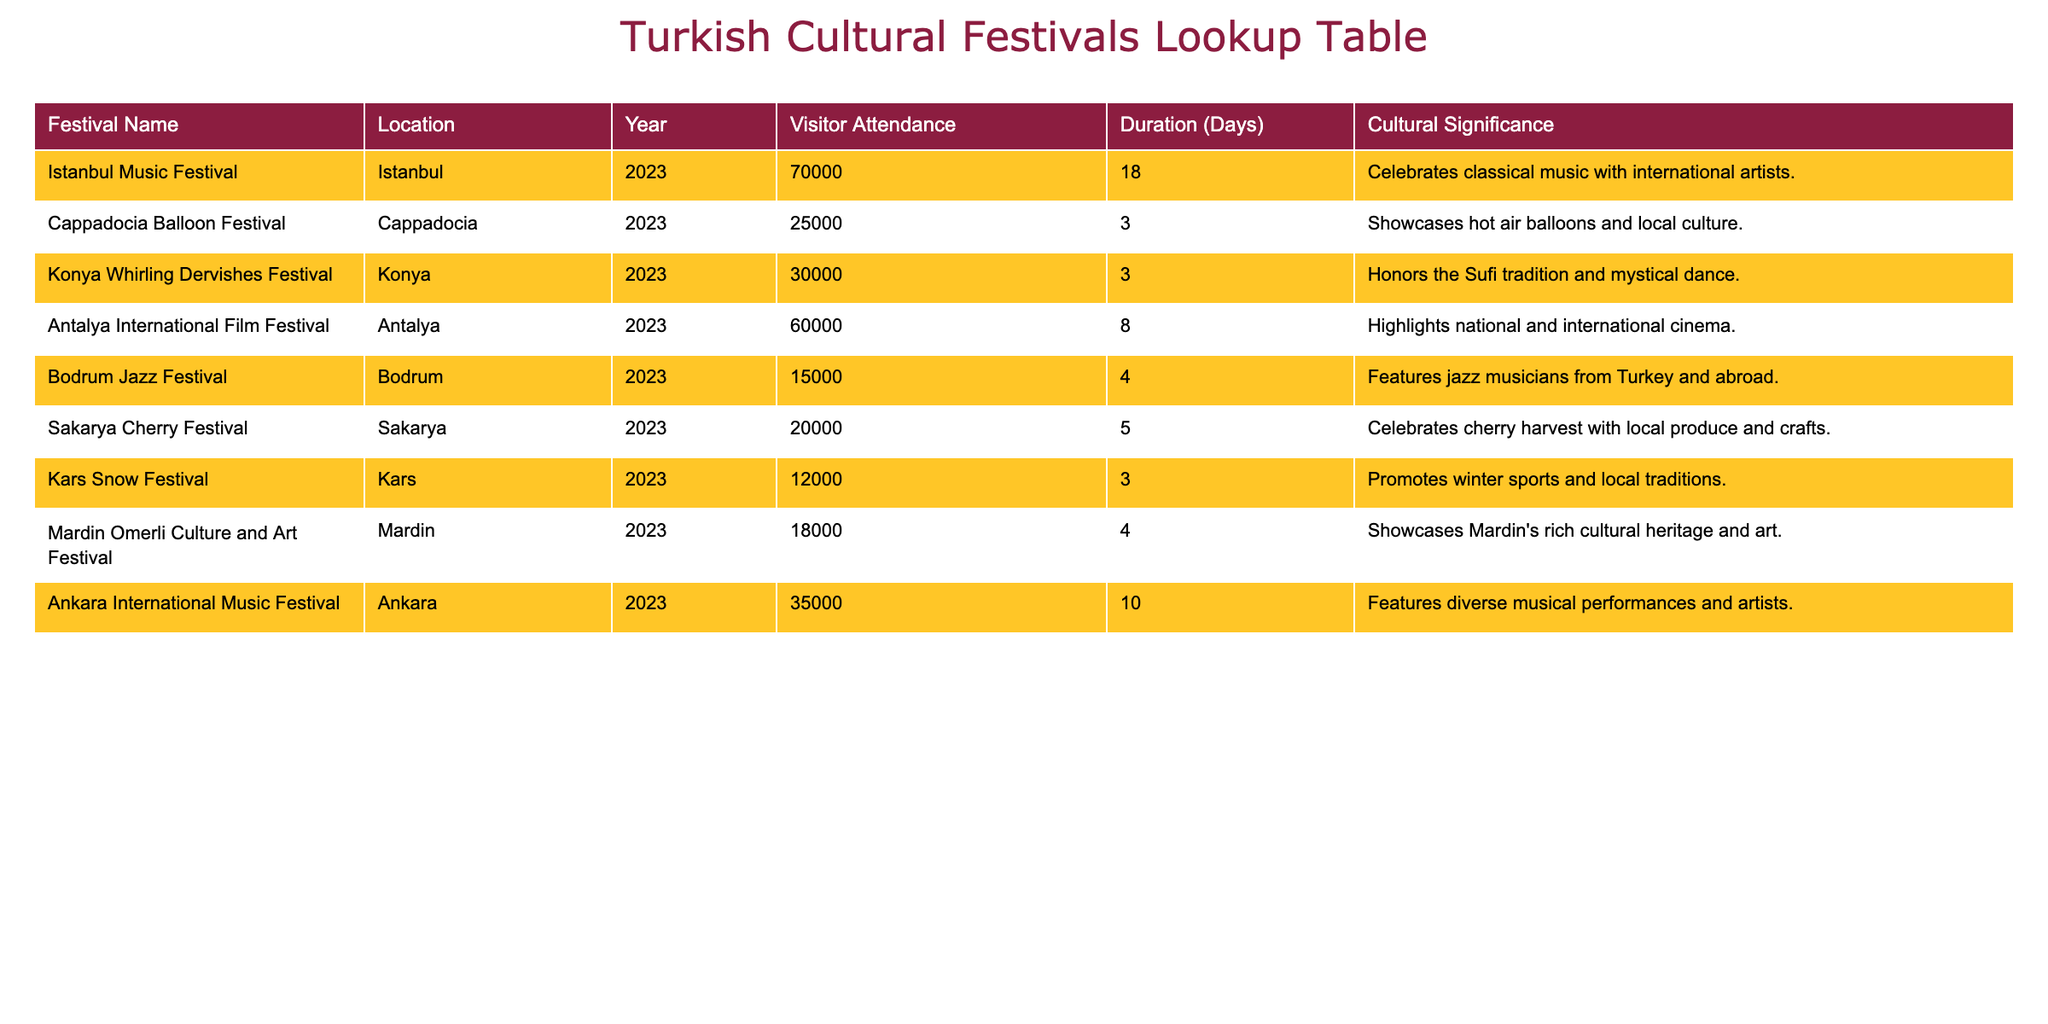What is the visitor attendance for the Istanbul Music Festival in 2023? The table shows that the Istanbul Music Festival in 2023 had a visitor attendance of 70,000.
Answer: 70,000 Which festival had the lowest visitor attendance in 2023? Referring to the table, the Kars Snow Festival had the lowest attendance with 12,000 visitors.
Answer: 12,000 What is the total visitor attendance for all festivals listed in 2023? By adding the visitor attendance numbers (70,000 + 25,000 + 30,000 + 60,000 + 15,000 + 20,000 + 12,000 + 18,000 + 35,000), the total is  325,000 visitors.
Answer: 325,000 Is the Antalya International Film Festival longer than 10 days? According to the table, the Antalya International Film Festival lasts for 8 days, which is less than 10 days.
Answer: No How many festivals had a duration of 3 days? Looking at the table, three festivals had a duration of 3 days: Cappadocia Balloon Festival, Konya Whirling Dervishes Festival, and Kars Snow Festival.
Answer: 3 What is the average visitor attendance for festivals lasting more than 4 days? The festivals lasting more than 4 days are the Istanbul Music Festival (70,000), Antalya International Film Festival (60,000), and Ankara International Music Festival (35,000). Summing their attendance gives 165,000. They are 3 in total, so the average is 165,000 / 3 = 55,000.
Answer: 55,000 Did the Sakarya Cherry Festival attract more visitors than the Bodrum Jazz Festival? According to the table, the Sakarya Cherry Festival attracted 20,000 visitors, while the Bodrum Jazz Festival attracted 15,000 visitors. Therefore, the Sakarya Cherry Festival had more visitors.
Answer: Yes What percentage of the total visitor attendance does the Konya Whirling Dervishes Festival represent? The Konya Whirling Dervishes Festival had 30,000 visitors out of a total of 325,000. To find the percentage, (30,000 / 325,000) * 100 equals approximately 9.23%.
Answer: 9.23% 